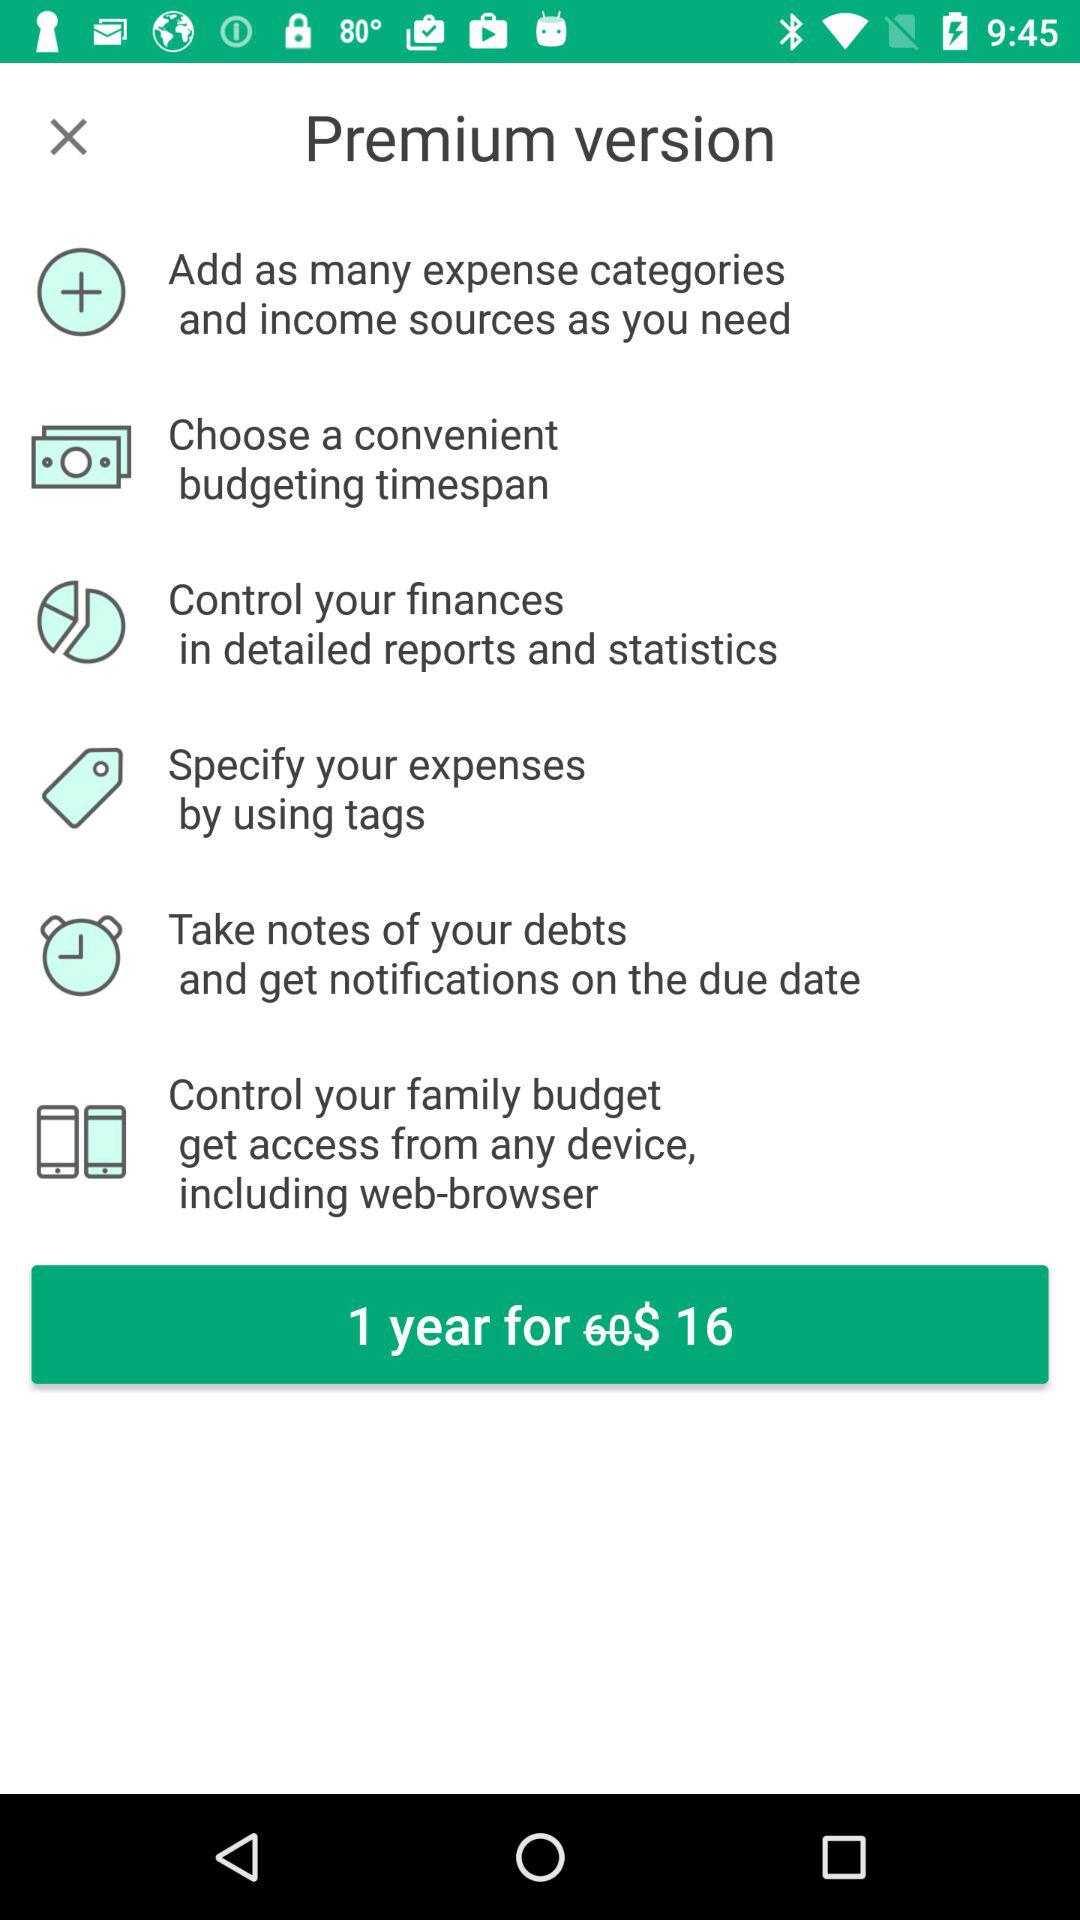What is the price of a one-year premium version? The price is $16. 